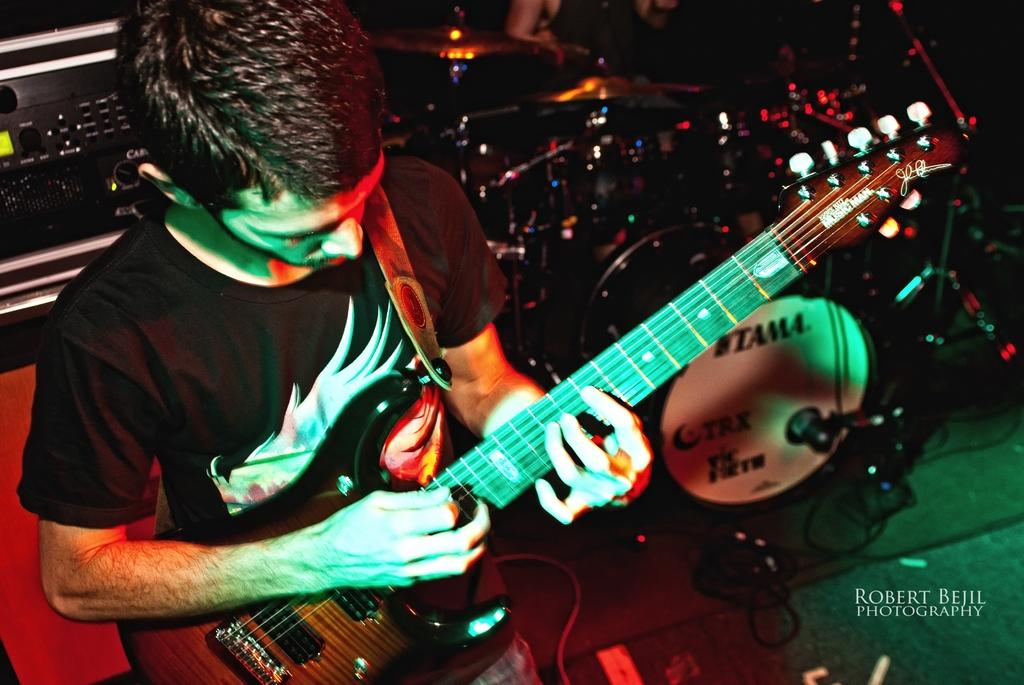What is the person in the image doing? The person is playing a guitar. What other objects related to the activity can be seen in the image? There are musical instruments in the background. How many goldfish are swimming in the wax in the image? There are no goldfish or wax present in the image. 